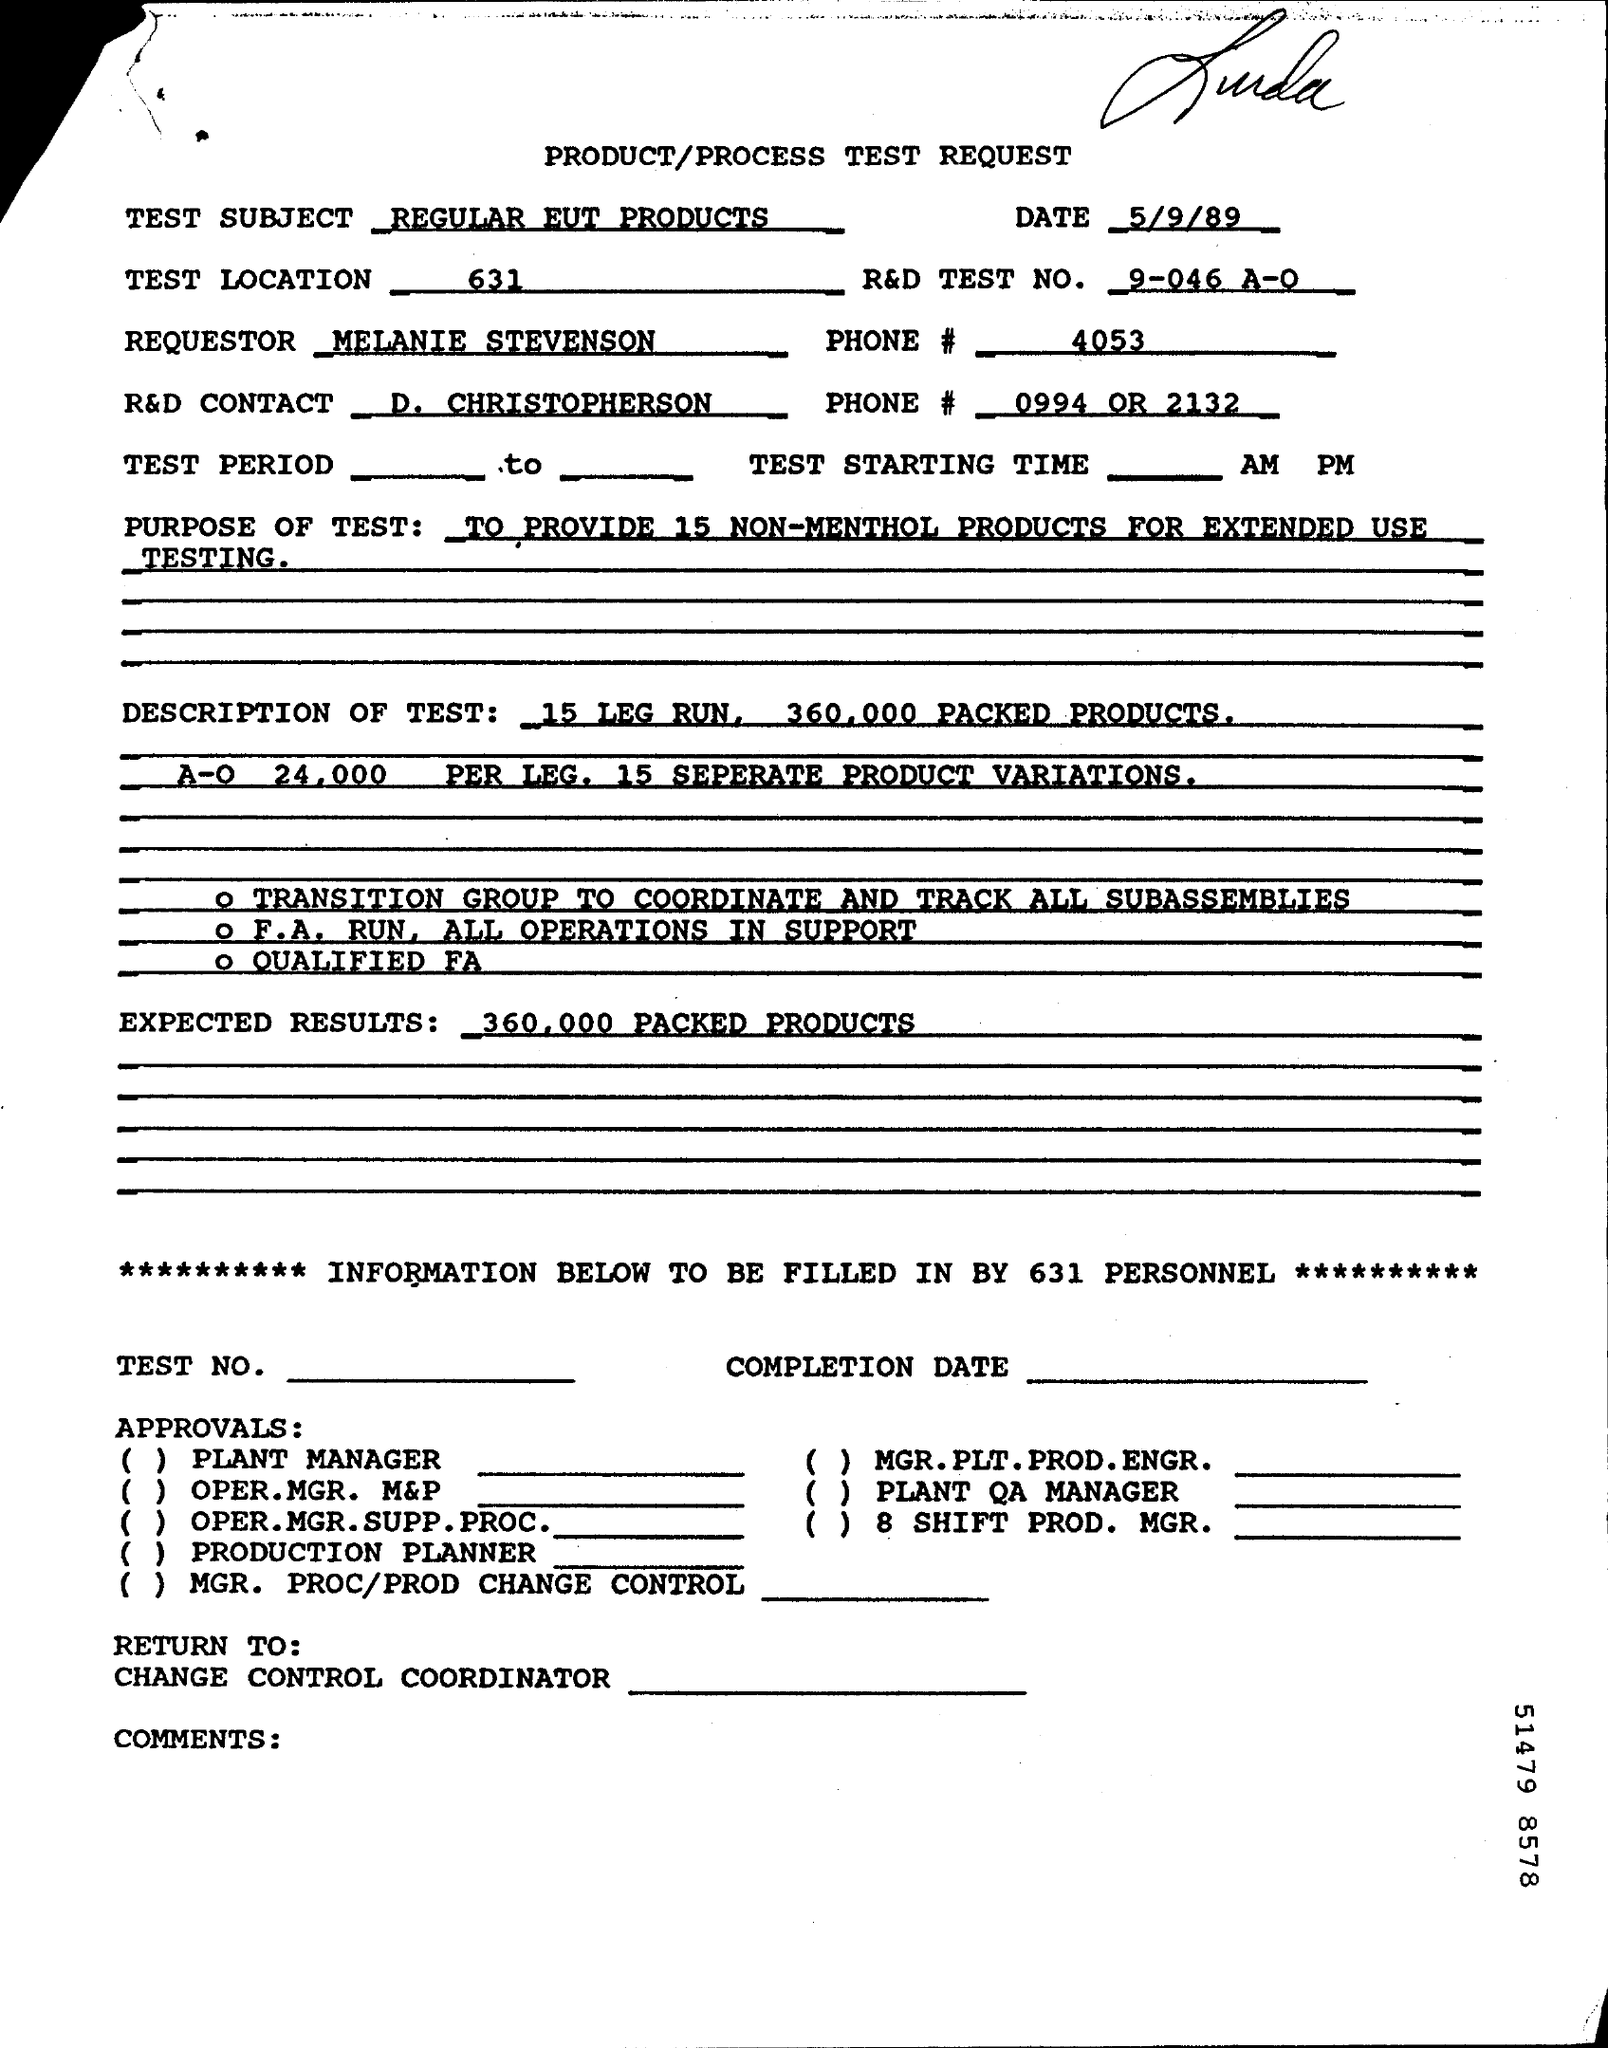What is test location no?
Provide a succinct answer. 631. What is the phone number of requester?
Make the answer very short. 4053. What is expected result?
Provide a short and direct response. 360,000 packed products. 